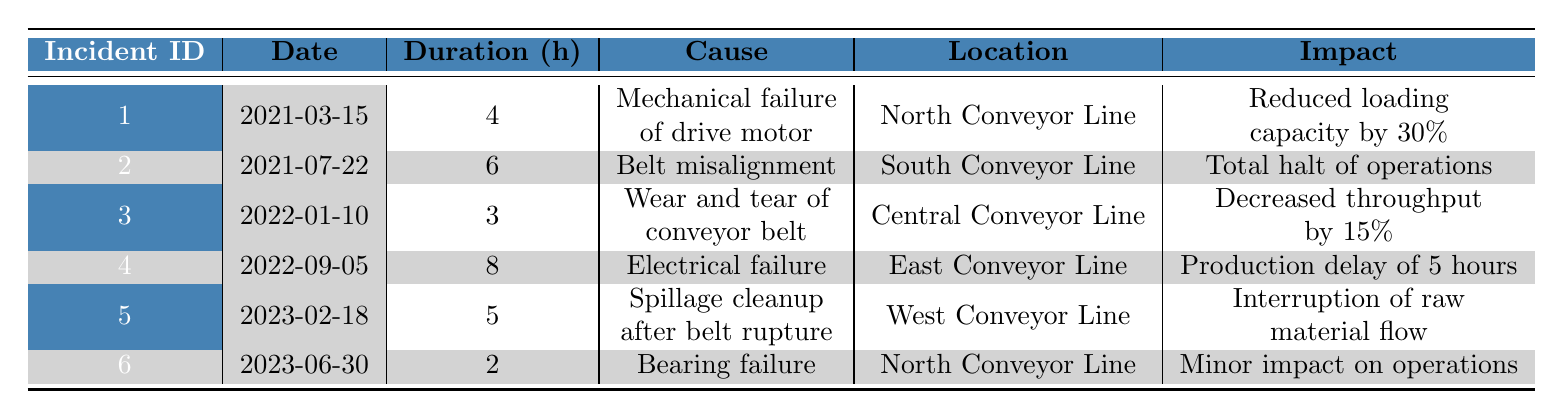What incident caused the longest downtime? By checking the "Duration (h)" column, the maximum value is 8 hours, which corresponds to incident ID 4 on "2022-09-05" due to electrical failure on the East Conveyor Line.
Answer: Incident ID 4 How many total hours of downtime occurred across all incidents? Adding up the "Duration (h)" values: 4 + 6 + 3 + 8 + 5 + 2 = 28 total hours of downtime across the incidents.
Answer: 28 Was there an incident that caused a total halt of operations? Incident ID 2 on "2021-07-22" is noted to have caused a total halt of operations due to belt misalignment.
Answer: Yes Which conveyor line experienced the most downtime due to incidents? Reviewing the incidents, the South Conveyor Line had 6 hours (incident ID 2), East Conveyor Line had 8 hours (incident ID 4), and no other line exceeded these hours; thus, the East Conveyor Line had the most downtime.
Answer: East Conveyor Line What is the average duration of downtime for all incidents? Summing all durations gives 28 hours, and dividing by the number of incidents (6) results in an average downtime of 4.67 hours per incident.
Answer: 4.67 hours Did any incidents affect Iron Ore? Incidents ID 1 and ID 6 relate to Iron Ore; therefore, two incidents affected Iron Ore.
Answer: Yes Which cause of failure was reported for the shortest downtime incident? The incident with the shortest downtime is ID 6 with 2 hours due to bearing failure, as per the "Duration (h)" column.
Answer: Incident ID 6 How many incidents had a direct impact on the flow of raw materials? Incidents that impacted material flow are IDs 2 (total halt), 5 (interruption), and ID 1 (reduced capacity), totaling three incidents affecting raw material flow.
Answer: 3 incidents What material was affected by the longest downtime incident? The longest downtime incident is ID 4, which affected Limestone due to electrical failure.
Answer: Limestone 